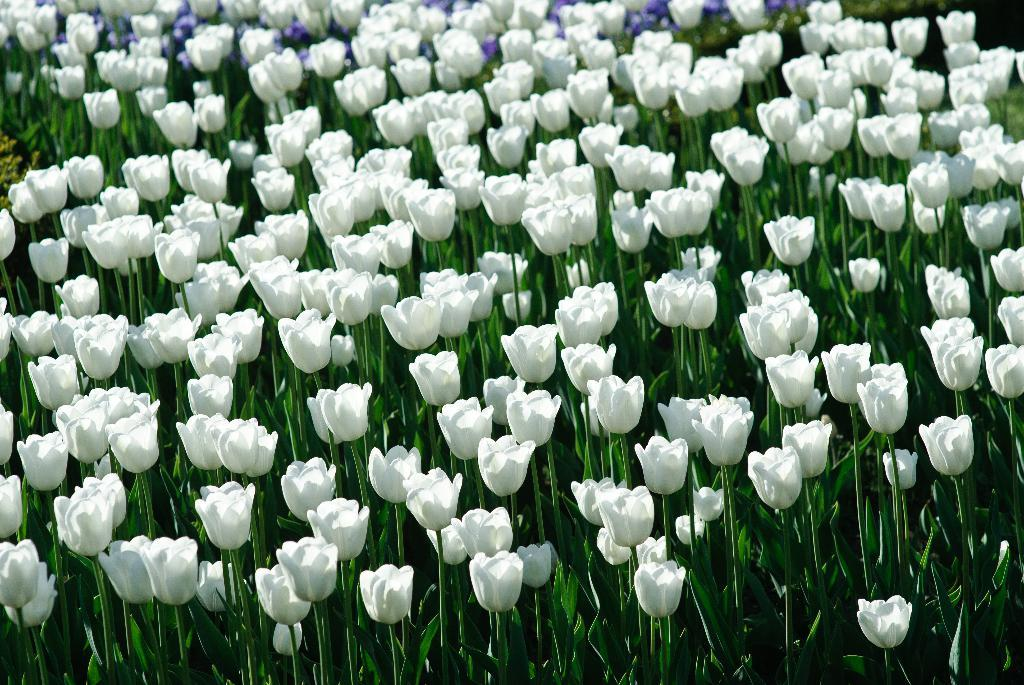What type of living organisms can be seen in the image? Plants can be seen in the image. What specific features do the plants have? The plants have flowers and leaves. What colors are the flowers? The flowers are in white and blue colors. What is the stranger doing in the downtown area in the image? There is no stranger or downtown area present in the image; it features plants with flowers and leaves. 